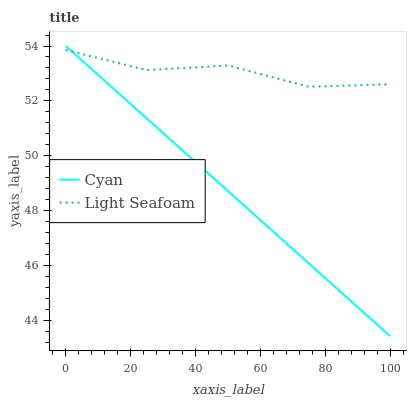Does Light Seafoam have the minimum area under the curve?
Answer yes or no. No. Is Light Seafoam the smoothest?
Answer yes or no. No. Does Light Seafoam have the lowest value?
Answer yes or no. No. Does Light Seafoam have the highest value?
Answer yes or no. No. 